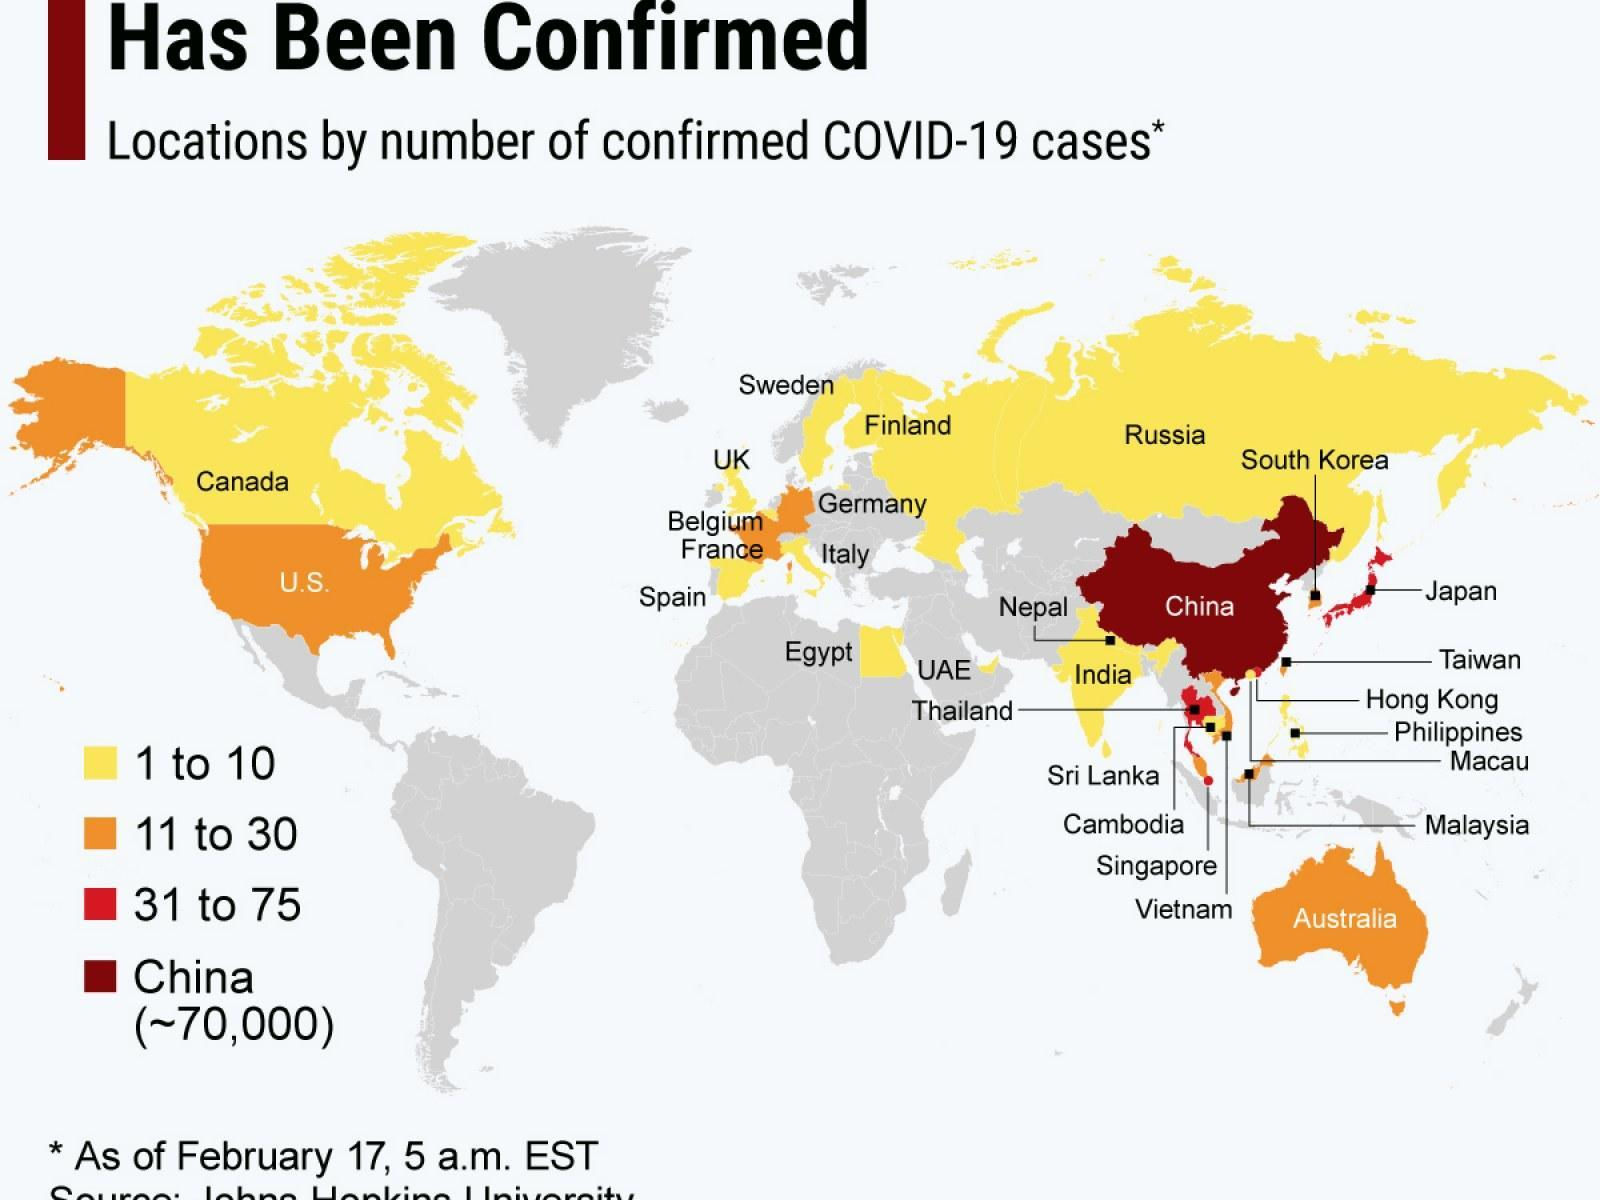How many cases of coronavirus has been confirmed in Canada?
Answer the question with a short phrase. 1 to 10 Which country has been reported more covid-19 cases among India, Australia, UAE? Australia How many cases of coronavirus has been confirmed in Australia? 11 to 30 Which country has been reported less covid-19 cases among China, UAE, Australia? UAE How many cases of coronavirus has been confirmed in Japan? 31 to 75 Which country has been reported less covid-19 cases among Canada and Japan? Canada Which country has been reported more covid-19 cases among Thailand, Philippines and Malaysia? Thailand How many cases of coronavirus has been confirmed in US? 11 to 30 Which country has been reported more covid-19 cases among US and Sweden? US How many cases of coronavirus has been confirmed in India? 1 to 10 